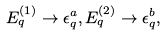<formula> <loc_0><loc_0><loc_500><loc_500>E ^ { ( 1 ) } _ { q } \rightarrow \epsilon _ { q } ^ { a } , E ^ { ( 2 ) } _ { q } \rightarrow \epsilon _ { q } ^ { b } ,</formula> 